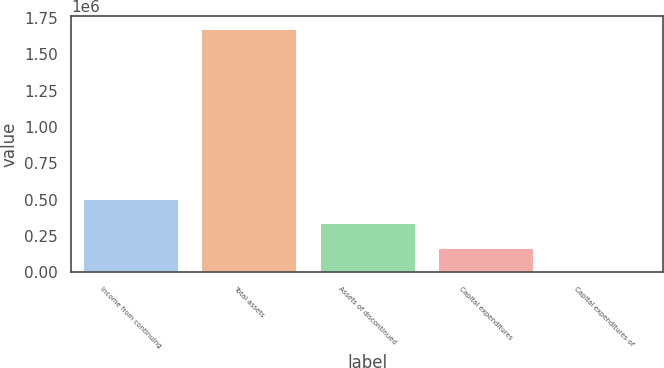Convert chart. <chart><loc_0><loc_0><loc_500><loc_500><bar_chart><fcel>Income from continuing<fcel>Total assets<fcel>Assets of discontinued<fcel>Capital expenditures<fcel>Capital expenditures of<nl><fcel>502939<fcel>1.67646e+06<fcel>335292<fcel>167646<fcel>0.34<nl></chart> 